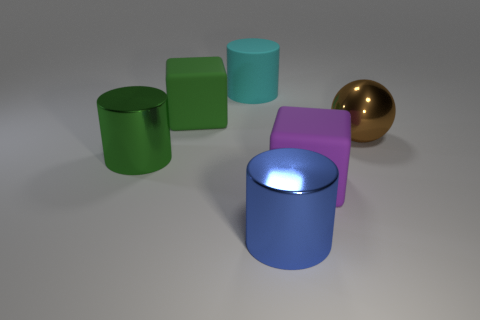Subtract all big metallic cylinders. How many cylinders are left? 1 Subtract 0 gray balls. How many objects are left? 6 Subtract all spheres. How many objects are left? 5 Subtract 1 cylinders. How many cylinders are left? 2 Subtract all green cylinders. Subtract all green spheres. How many cylinders are left? 2 Subtract all cyan cubes. How many green cylinders are left? 1 Subtract all objects. Subtract all tiny blue cylinders. How many objects are left? 0 Add 3 big things. How many big things are left? 9 Add 5 big blue shiny cylinders. How many big blue shiny cylinders exist? 6 Add 1 small cyan shiny spheres. How many objects exist? 7 